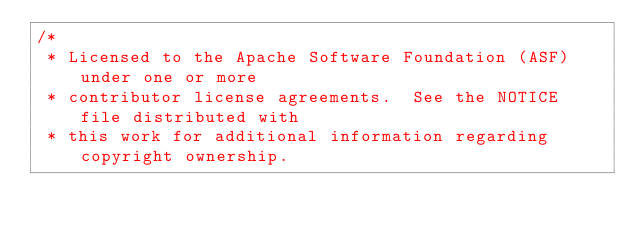Convert code to text. <code><loc_0><loc_0><loc_500><loc_500><_Scala_>/*
 * Licensed to the Apache Software Foundation (ASF) under one or more
 * contributor license agreements.  See the NOTICE file distributed with
 * this work for additional information regarding copyright ownership.</code> 